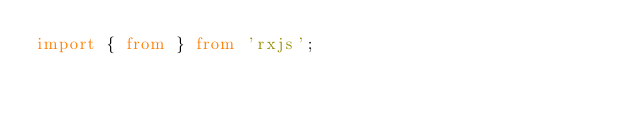<code> <loc_0><loc_0><loc_500><loc_500><_TypeScript_>import { from } from 'rxjs';

</code> 